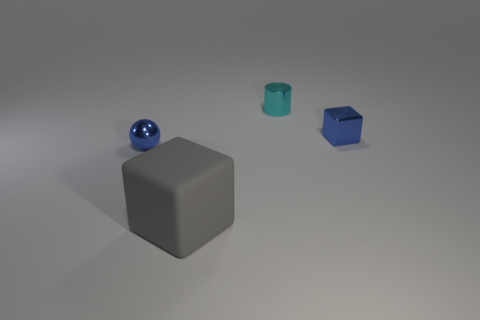Add 2 big rubber objects. How many objects exist? 6 Subtract all balls. How many objects are left? 3 Add 2 small shiny cylinders. How many small shiny cylinders are left? 3 Add 1 tiny cyan metallic cylinders. How many tiny cyan metallic cylinders exist? 2 Subtract 1 blue blocks. How many objects are left? 3 Subtract all shiny blocks. Subtract all big things. How many objects are left? 2 